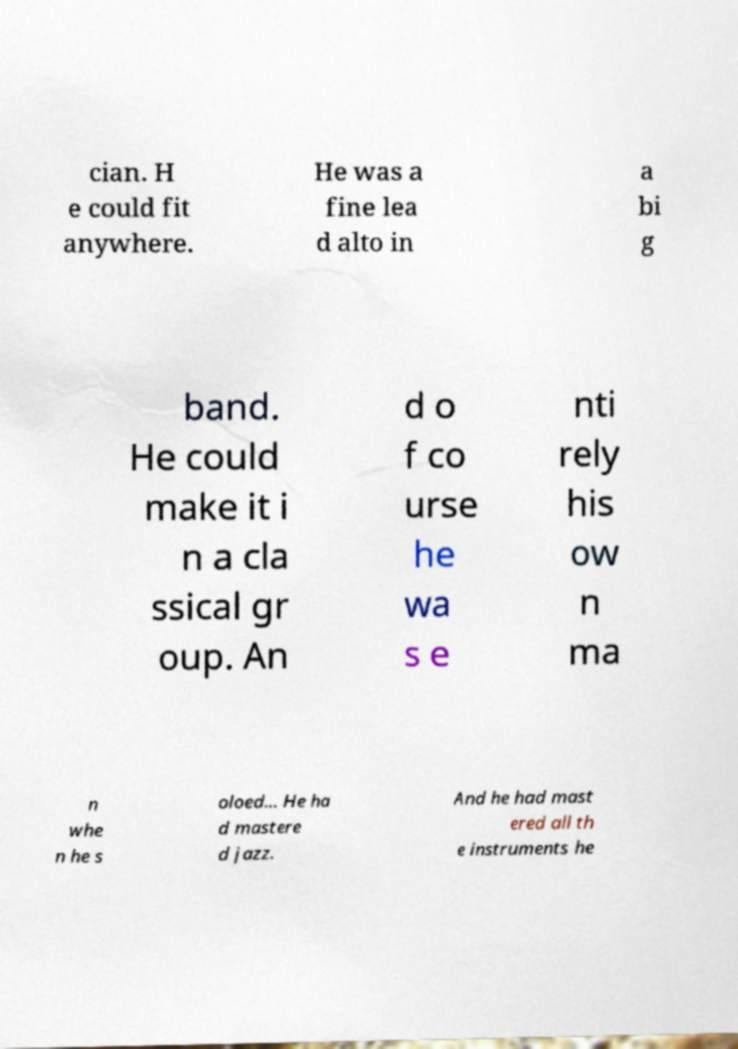Please read and relay the text visible in this image. What does it say? cian. H e could fit anywhere. He was a fine lea d alto in a bi g band. He could make it i n a cla ssical gr oup. An d o f co urse he wa s e nti rely his ow n ma n whe n he s oloed... He ha d mastere d jazz. And he had mast ered all th e instruments he 